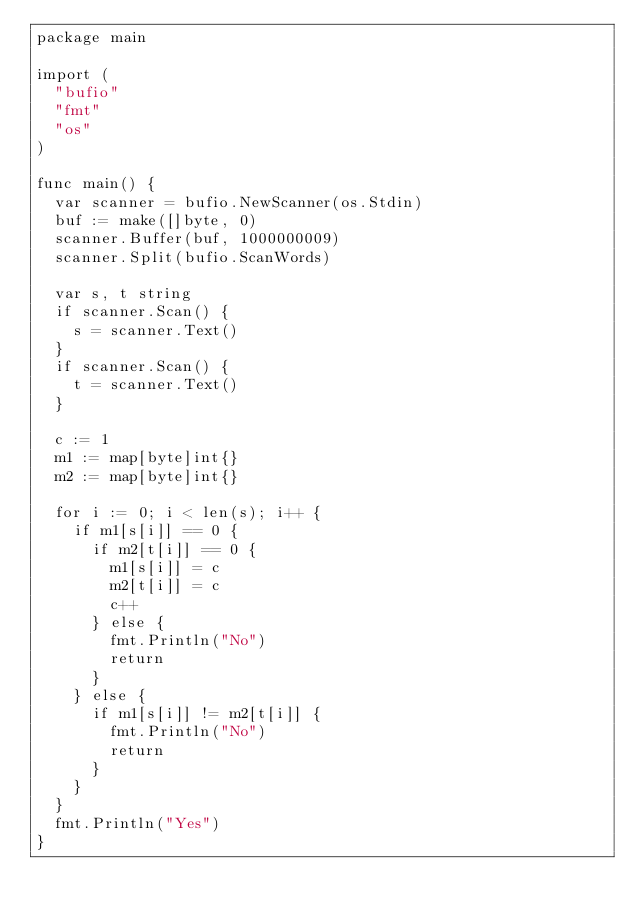<code> <loc_0><loc_0><loc_500><loc_500><_Go_>package main
 
import (
	"bufio"
	"fmt"
	"os"
)
 
func main() {
	var scanner = bufio.NewScanner(os.Stdin)
 	buf := make([]byte, 0)
	scanner.Buffer(buf, 1000000009)
	scanner.Split(bufio.ScanWords)
 
	var s, t string
	if scanner.Scan() {
		s = scanner.Text()
	}
	if scanner.Scan() {
		t = scanner.Text()
	}
 
	c := 1
	m1 := map[byte]int{}
	m2 := map[byte]int{}
 
	for i := 0; i < len(s); i++ {
		if m1[s[i]] == 0 {
			if m2[t[i]] == 0 {
				m1[s[i]] = c
				m2[t[i]] = c
				c++
			} else {
				fmt.Println("No")
				return
			}
		} else {
			if m1[s[i]] != m2[t[i]] {
				fmt.Println("No")
				return
			}
		}
	}
	fmt.Println("Yes")
}</code> 